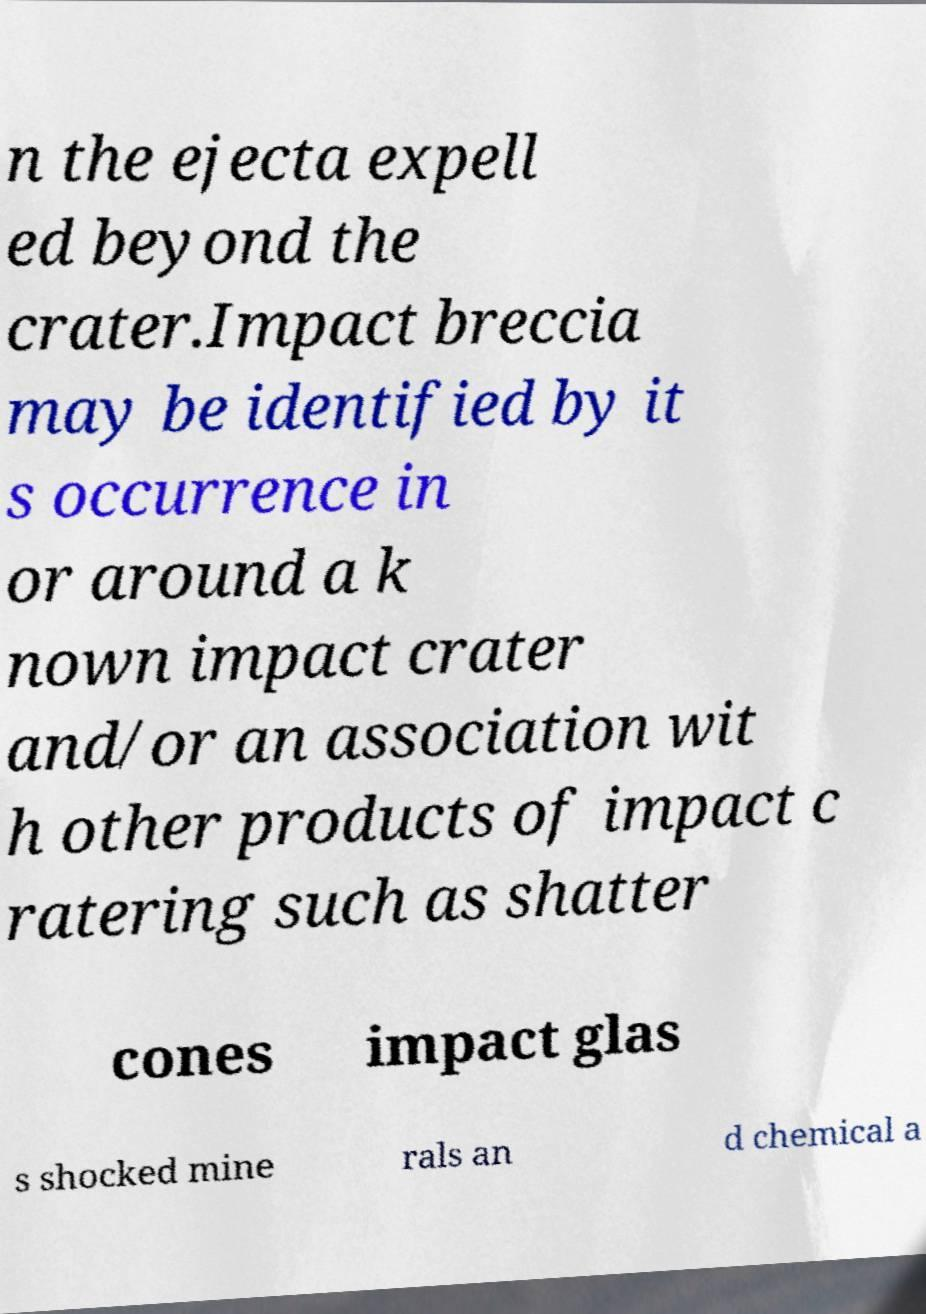For documentation purposes, I need the text within this image transcribed. Could you provide that? n the ejecta expell ed beyond the crater.Impact breccia may be identified by it s occurrence in or around a k nown impact crater and/or an association wit h other products of impact c ratering such as shatter cones impact glas s shocked mine rals an d chemical a 